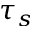<formula> <loc_0><loc_0><loc_500><loc_500>\tau _ { s }</formula> 